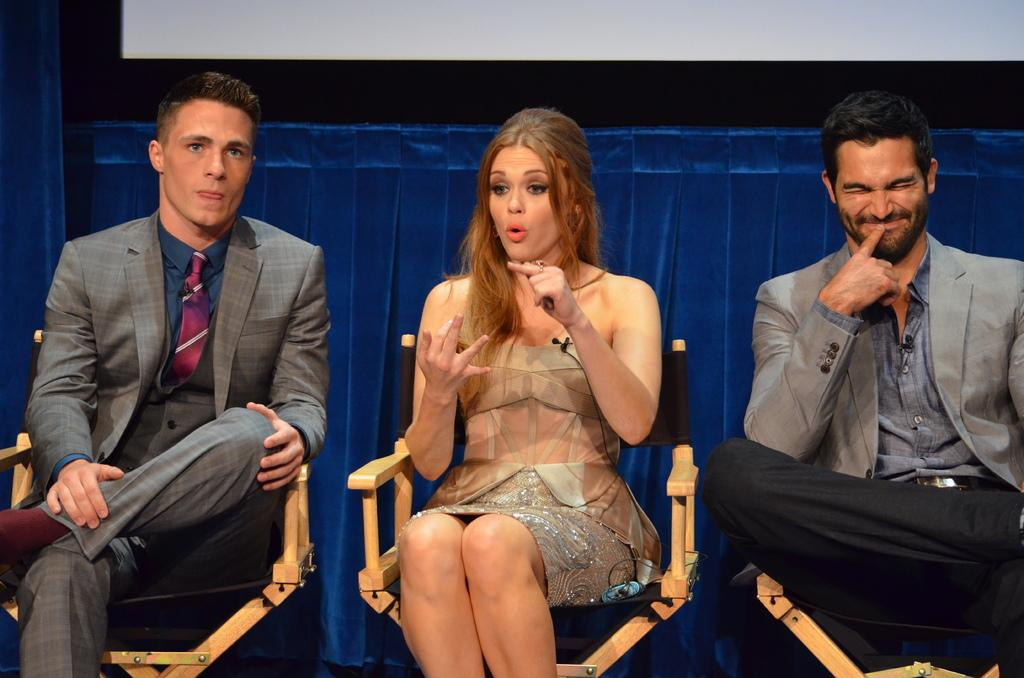What are the people in the image doing? The people in the image are sitting in the center. What are the people sitting on? The people are sitting on chairs. What can be seen in the background of the image? There is a blue color curtain in the background of the image. What type of apparatus is being used by the people in the image? There is no apparatus visible in the image; the people are simply sitting on chairs. Is it raining in the image? The image does not provide any information about the weather, so we cannot determine if it is raining or not. 